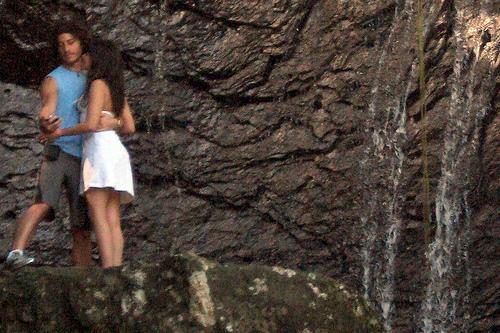How many people are in this photo?
Give a very brief answer. 2. 